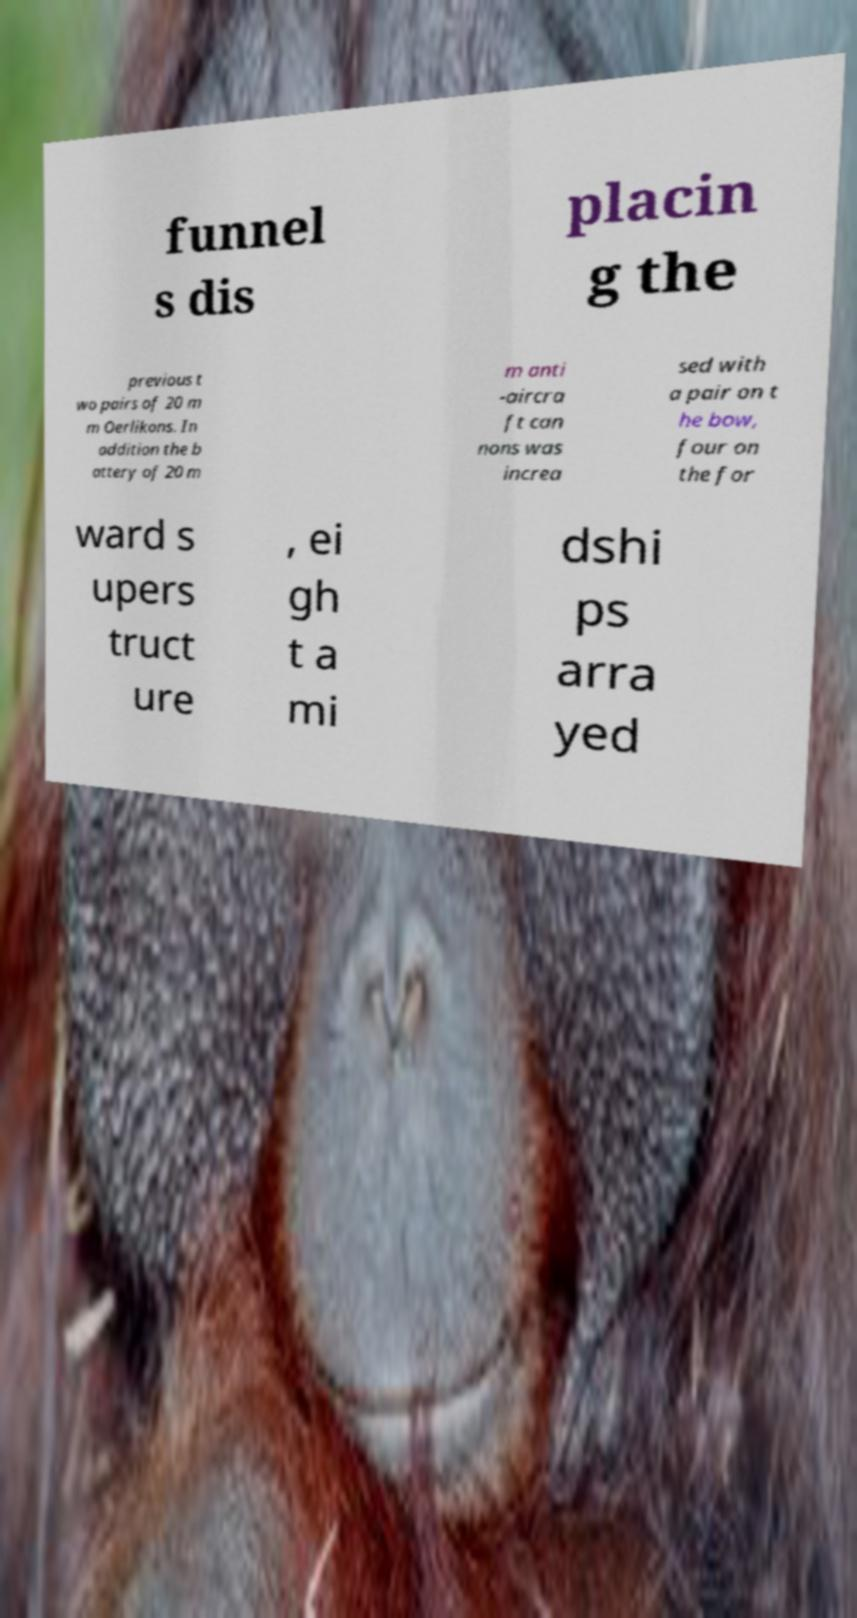For documentation purposes, I need the text within this image transcribed. Could you provide that? funnel s dis placin g the previous t wo pairs of 20 m m Oerlikons. In addition the b attery of 20 m m anti -aircra ft can nons was increa sed with a pair on t he bow, four on the for ward s upers truct ure , ei gh t a mi dshi ps arra yed 